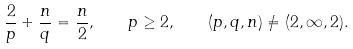<formula> <loc_0><loc_0><loc_500><loc_500>\frac { 2 } { p } + \frac { n } { q } = \frac { n } { 2 } , \quad p \geq 2 , \quad ( p , q , n ) \neq ( 2 , \infty , 2 ) .</formula> 